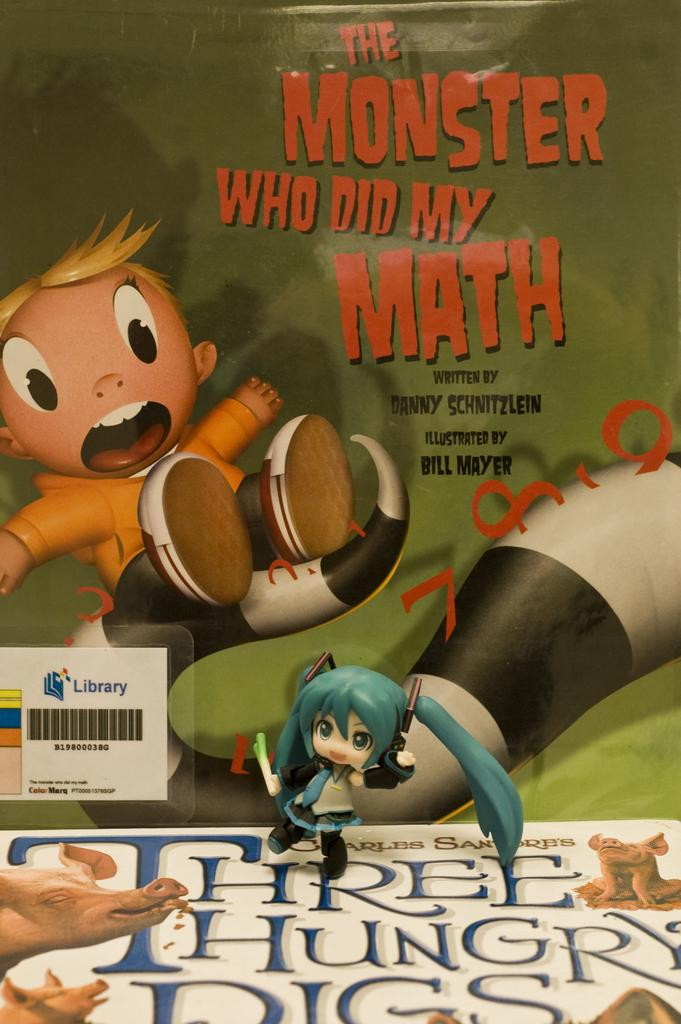What is the medium of the image? The image is on a paper. What type of content is depicted in the image? There is animation in the image. Can you describe the character on the left side of the image? There is a boy on the left side of the image. How does the boy smash the animation in the image? There is no indication in the image that the boy is smashing the animation; he is simply depicted on the left side. 